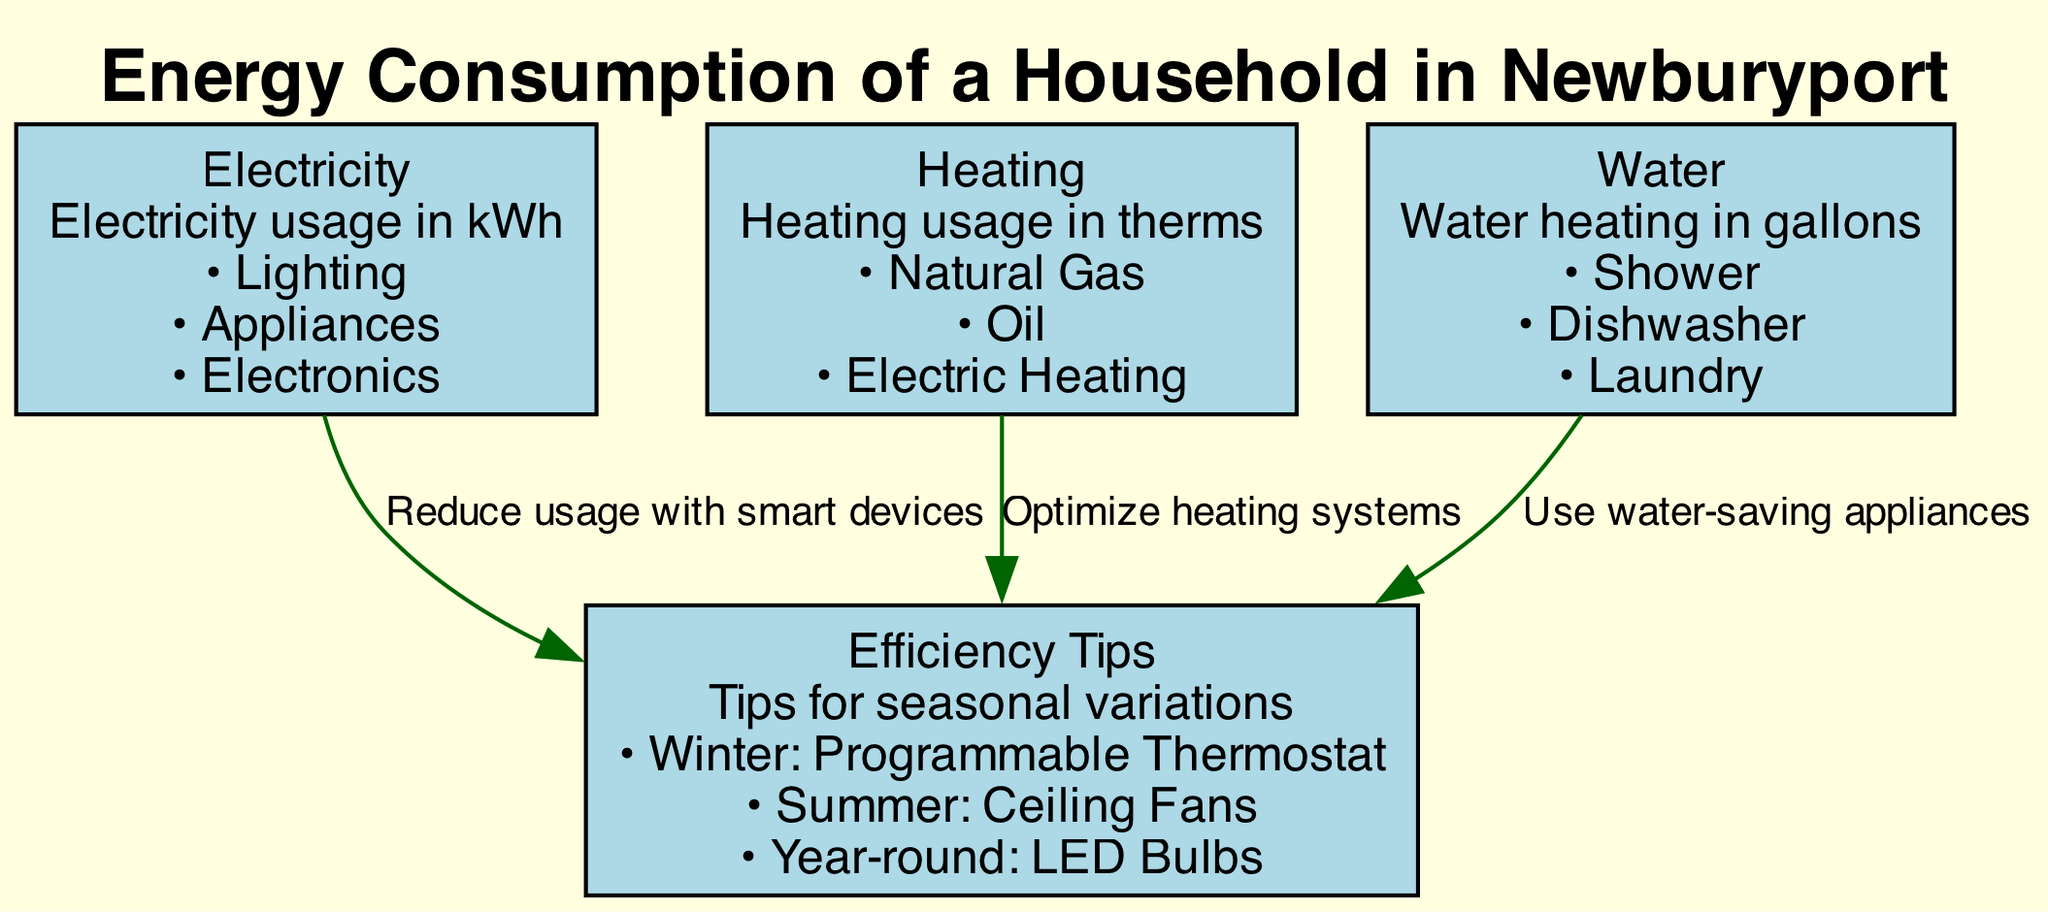What are the three main categories of energy consumption in the diagram? The diagram lists three main categories: Electricity, Heating, and Water. Each category is represented as a distinct node in the diagram showing their respective usage metrics.
Answer: Electricity, Heating, Water How many details are provided under the "Heating" node? The "Heating" node has three specific details listed: Natural Gas, Oil, and Electric Heating. By counting the details under the node, we arrive at this number.
Answer: 3 Which efficiency tip is associated with "Heating"? Referring to the edges in the diagram, the edge connecting "Heating" to "Efficiency Tips" indicates that the associated tip is "Optimize heating systems." This shows the specific recommendation tied to this energy category.
Answer: Optimize heating systems What is the relationship between "Electricity" and "Efficiency Tips"? The diagram shows a directed edge from "Electricity" to "Efficiency Tips" labeled "Reduce usage with smart devices." This indicates that the focus on reducing electricity usage connects directly to the tips provided for efficiency.
Answer: Reduce usage with smart devices How many nodes are there in total in the diagram? By counting the nodes present in the diagram, which include Electricity, Heating, Water, and Efficiency Tips, we determine that there are four main nodes in total.
Answer: 4 What is the specific efficiency tip for summer? Under "Efficiency Tips," one of the details mentions "Summer: Ceiling Fans." This information can be directly extracted from the details of the tips node that are categorized based on seasonal variations.
Answer: Ceiling Fans Which detail falls under the "Water" category? The "Water" node lists three details, including Shower, Dishwasher, and Laundry. Any one of these details can be confirmed as a representative of water consumption in households.
Answer: Shower (or Dishwasher, or Laundry) How does the "Water" category relate to efficiency tips? The diagram displays an edge connecting "Water" to "Efficiency Tips" with the label "Use water-saving appliances." This shows the direct relationship emphasizing water conservation and efficiency through specific advice.
Answer: Use water-saving appliances What is one suggested efficiency tip that can be used year-round? Among the efficiency tips detailed in the "Efficiency Tips" node, "Year-round: LED Bulbs" is identified as a recommendation applicable throughout the entire year, ensuring continued efficiency in energy consumption.
Answer: LED Bulbs 